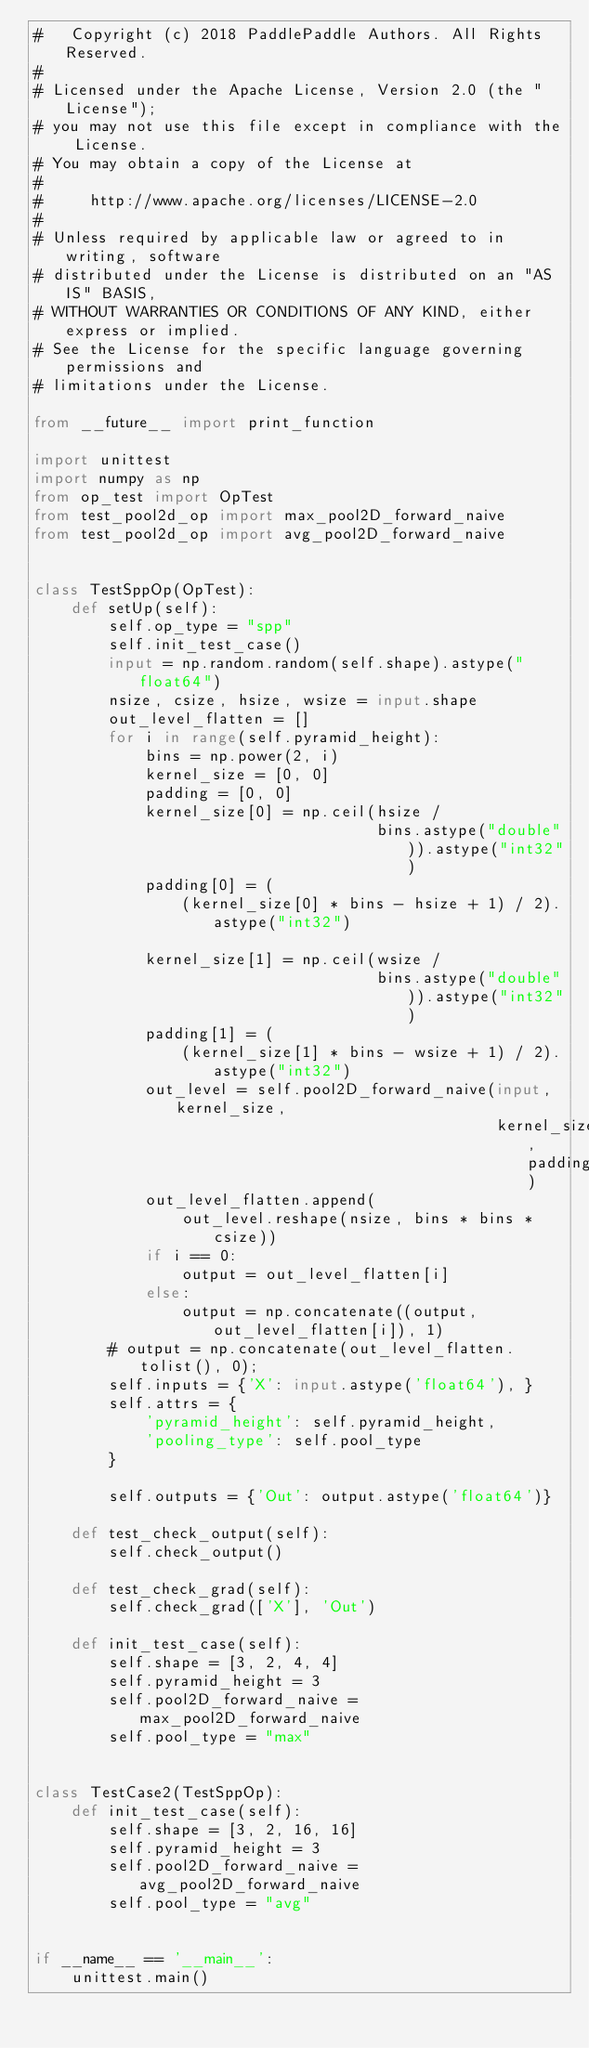Convert code to text. <code><loc_0><loc_0><loc_500><loc_500><_Python_>#   Copyright (c) 2018 PaddlePaddle Authors. All Rights Reserved.
#
# Licensed under the Apache License, Version 2.0 (the "License");
# you may not use this file except in compliance with the License.
# You may obtain a copy of the License at
#
#     http://www.apache.org/licenses/LICENSE-2.0
#
# Unless required by applicable law or agreed to in writing, software
# distributed under the License is distributed on an "AS IS" BASIS,
# WITHOUT WARRANTIES OR CONDITIONS OF ANY KIND, either express or implied.
# See the License for the specific language governing permissions and
# limitations under the License.

from __future__ import print_function

import unittest
import numpy as np
from op_test import OpTest
from test_pool2d_op import max_pool2D_forward_naive
from test_pool2d_op import avg_pool2D_forward_naive


class TestSppOp(OpTest):
    def setUp(self):
        self.op_type = "spp"
        self.init_test_case()
        input = np.random.random(self.shape).astype("float64")
        nsize, csize, hsize, wsize = input.shape
        out_level_flatten = []
        for i in range(self.pyramid_height):
            bins = np.power(2, i)
            kernel_size = [0, 0]
            padding = [0, 0]
            kernel_size[0] = np.ceil(hsize /
                                     bins.astype("double")).astype("int32")
            padding[0] = (
                (kernel_size[0] * bins - hsize + 1) / 2).astype("int32")

            kernel_size[1] = np.ceil(wsize /
                                     bins.astype("double")).astype("int32")
            padding[1] = (
                (kernel_size[1] * bins - wsize + 1) / 2).astype("int32")
            out_level = self.pool2D_forward_naive(input, kernel_size,
                                                  kernel_size, padding)
            out_level_flatten.append(
                out_level.reshape(nsize, bins * bins * csize))
            if i == 0:
                output = out_level_flatten[i]
            else:
                output = np.concatenate((output, out_level_flatten[i]), 1)
        # output = np.concatenate(out_level_flatten.tolist(), 0);
        self.inputs = {'X': input.astype('float64'), }
        self.attrs = {
            'pyramid_height': self.pyramid_height,
            'pooling_type': self.pool_type
        }

        self.outputs = {'Out': output.astype('float64')}

    def test_check_output(self):
        self.check_output()

    def test_check_grad(self):
        self.check_grad(['X'], 'Out')

    def init_test_case(self):
        self.shape = [3, 2, 4, 4]
        self.pyramid_height = 3
        self.pool2D_forward_naive = max_pool2D_forward_naive
        self.pool_type = "max"


class TestCase2(TestSppOp):
    def init_test_case(self):
        self.shape = [3, 2, 16, 16]
        self.pyramid_height = 3
        self.pool2D_forward_naive = avg_pool2D_forward_naive
        self.pool_type = "avg"


if __name__ == '__main__':
    unittest.main()
</code> 